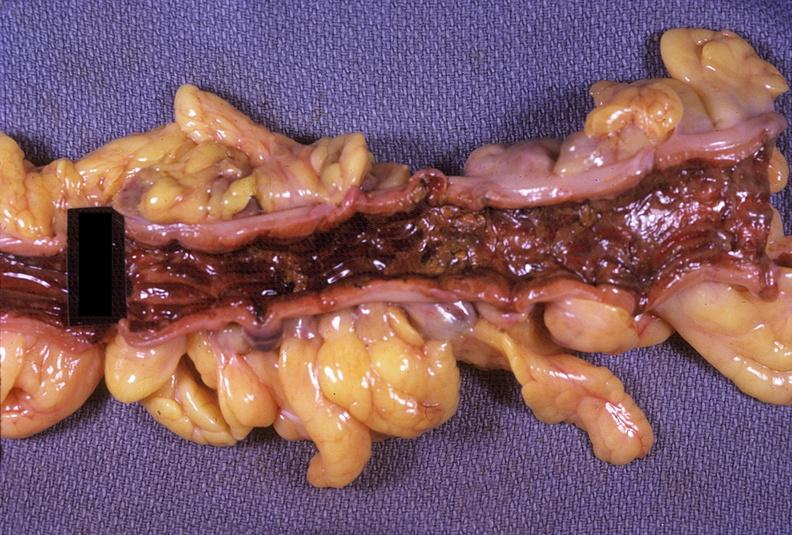does this image show colon, ulcerative colitis?
Answer the question using a single word or phrase. Yes 